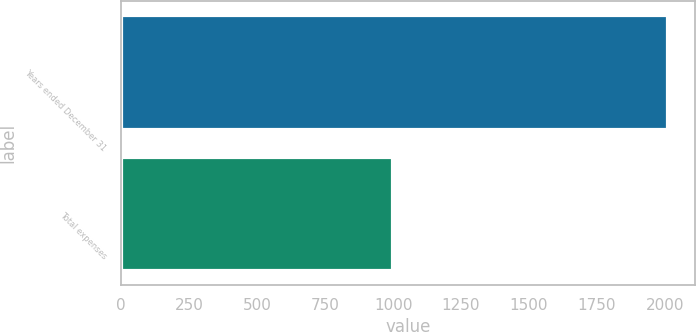Convert chart to OTSL. <chart><loc_0><loc_0><loc_500><loc_500><bar_chart><fcel>Years ended December 31<fcel>Total expenses<nl><fcel>2009<fcel>997<nl></chart> 